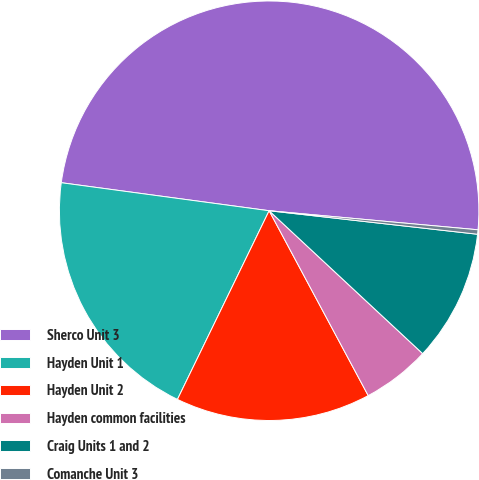Convert chart to OTSL. <chart><loc_0><loc_0><loc_500><loc_500><pie_chart><fcel>Sherco Unit 3<fcel>Hayden Unit 1<fcel>Hayden Unit 2<fcel>Hayden common facilities<fcel>Craig Units 1 and 2<fcel>Comanche Unit 3<nl><fcel>49.31%<fcel>19.93%<fcel>15.03%<fcel>5.24%<fcel>10.14%<fcel>0.34%<nl></chart> 